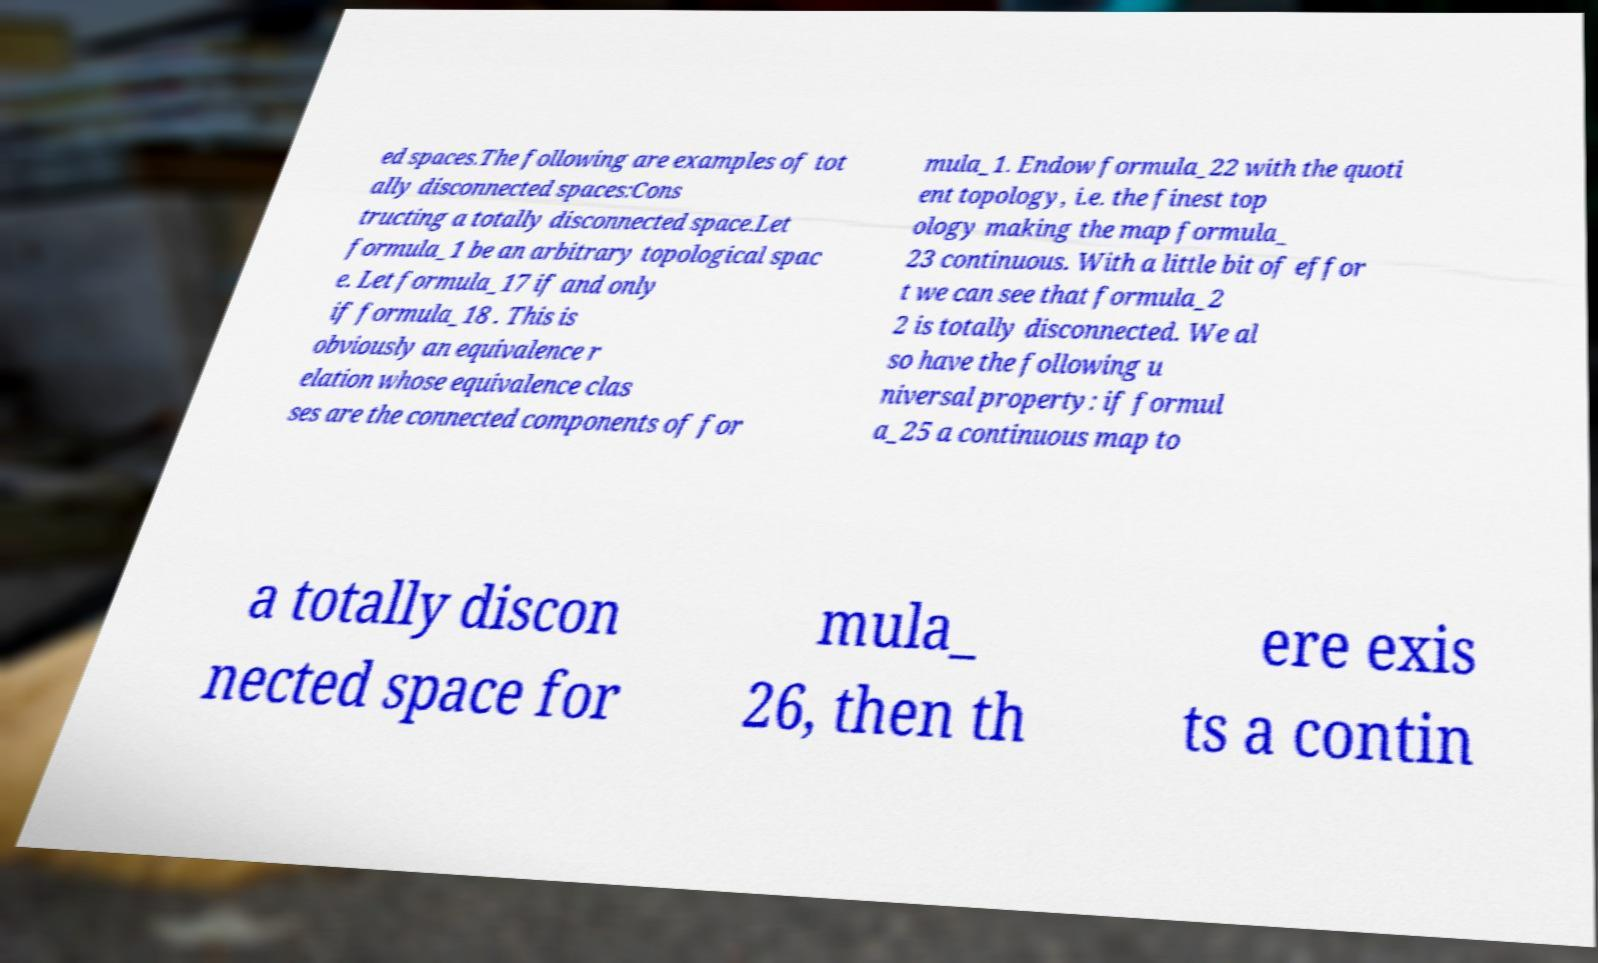Please identify and transcribe the text found in this image. ed spaces.The following are examples of tot ally disconnected spaces:Cons tructing a totally disconnected space.Let formula_1 be an arbitrary topological spac e. Let formula_17 if and only if formula_18 . This is obviously an equivalence r elation whose equivalence clas ses are the connected components of for mula_1. Endow formula_22 with the quoti ent topology, i.e. the finest top ology making the map formula_ 23 continuous. With a little bit of effor t we can see that formula_2 2 is totally disconnected. We al so have the following u niversal property: if formul a_25 a continuous map to a totally discon nected space for mula_ 26, then th ere exis ts a contin 